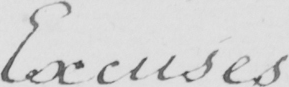Please transcribe the handwritten text in this image. Excuses 